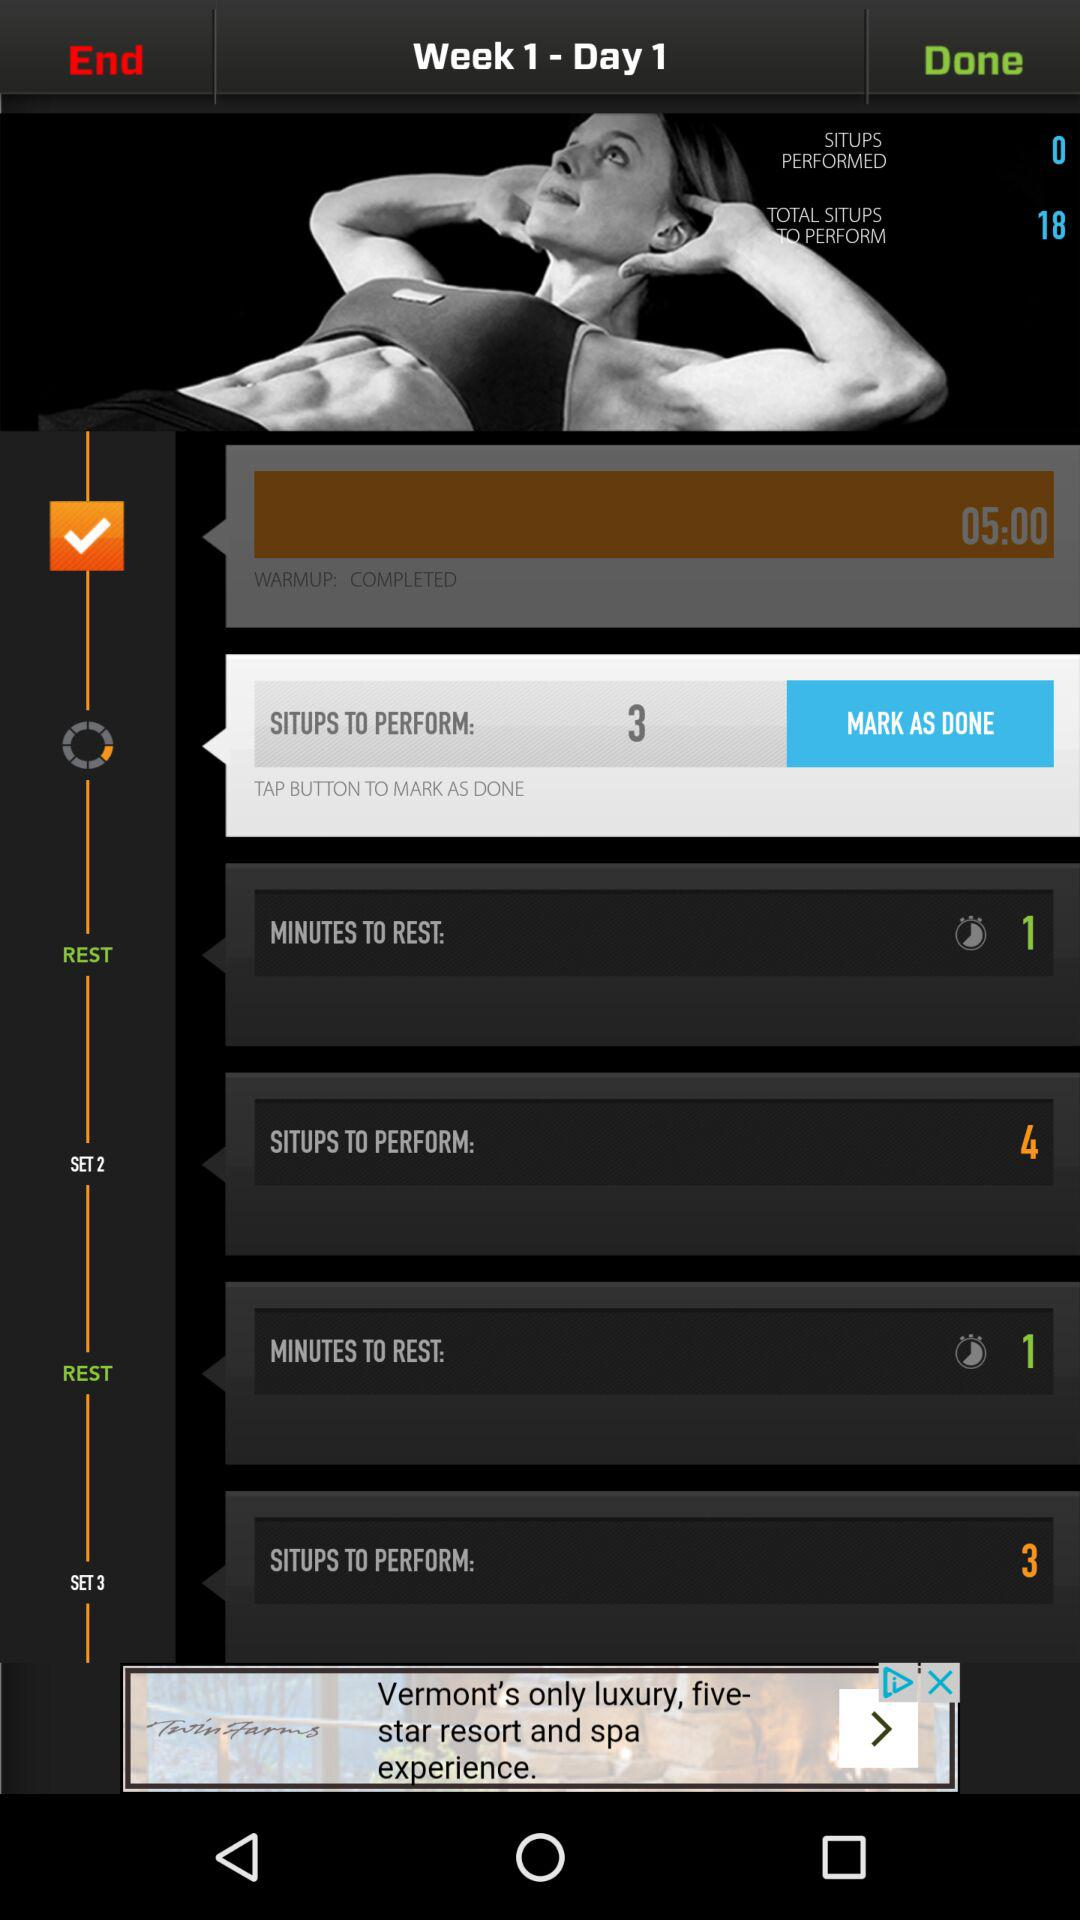What is the total number of situps performed? The total number of situps performed is 0. 